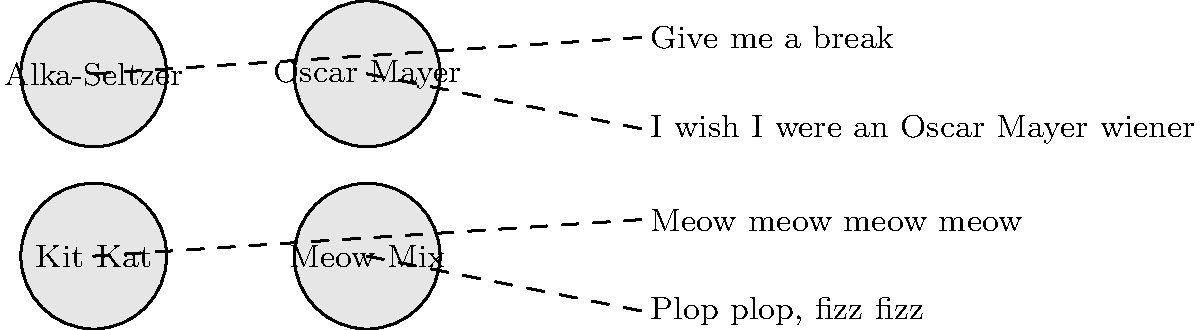Match the classic TV commercial jingles to their corresponding product logos by drawing lines between them. Which jingle belongs to which product? To match the jingles to their corresponding product logos, let's go through each one:

1. "Plop plop, fizz fizz" - This iconic jingle is associated with Alka-Seltzer, an effervescent antacid and pain reliever. The sound described in the jingle mimics the tablets dissolving in water.

2. "I wish I were an Oscar Mayer wiener" - This catchy tune is unmistakably linked to Oscar Mayer, the well-known processed meat company. The jingle was part of a long-running campaign that began in the 1960s.

3. "Give me a break" - This slogan, often sung in commercials, is associated with Kit Kat chocolate bars. The full jingle goes, "Give me a break, give me a break, break me off a piece of that Kit Kat bar!"

4. "Meow meow meow meow" - This simple yet effective jingle is instantly recognizable as the Meow Mix cat food commercial. The repetitive "meow" mimics a cat's vocalization and has been used in their advertising since the 1970s.

By matching these memorable jingles to their corresponding product logos, we can correctly connect each pair.
Answer: Alka-Seltzer: "Plop plop, fizz fizz"
Oscar Mayer: "I wish I were an Oscar Mayer wiener"
Kit Kat: "Give me a break"
Meow Mix: "Meow meow meow meow" 